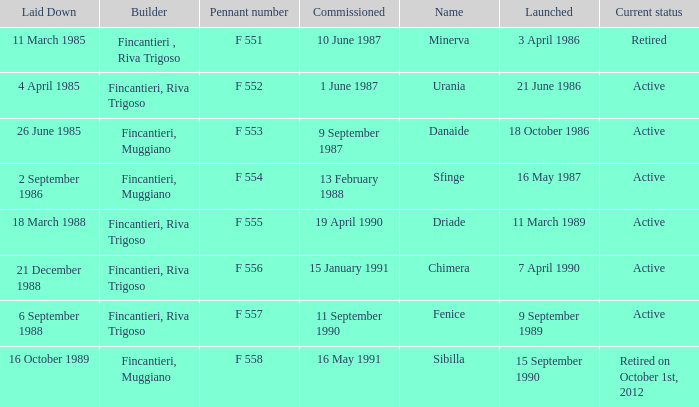What builder is now retired F 551. 